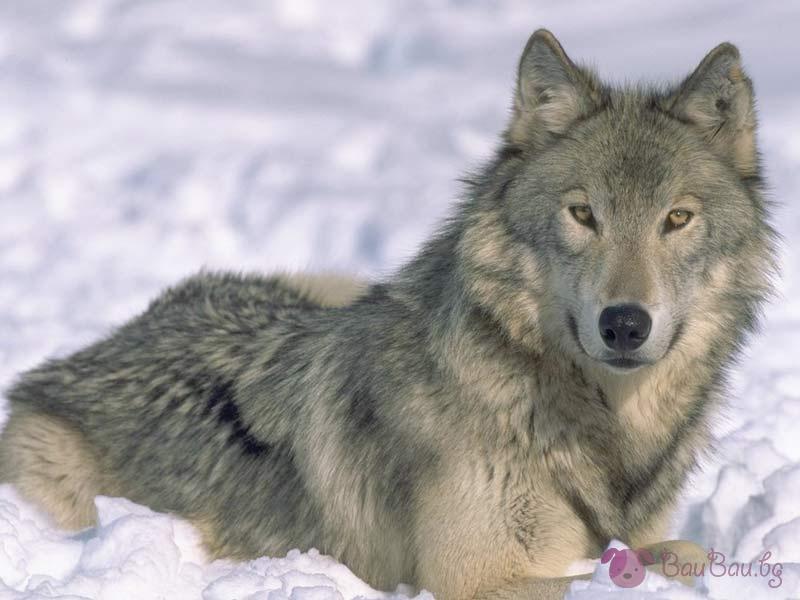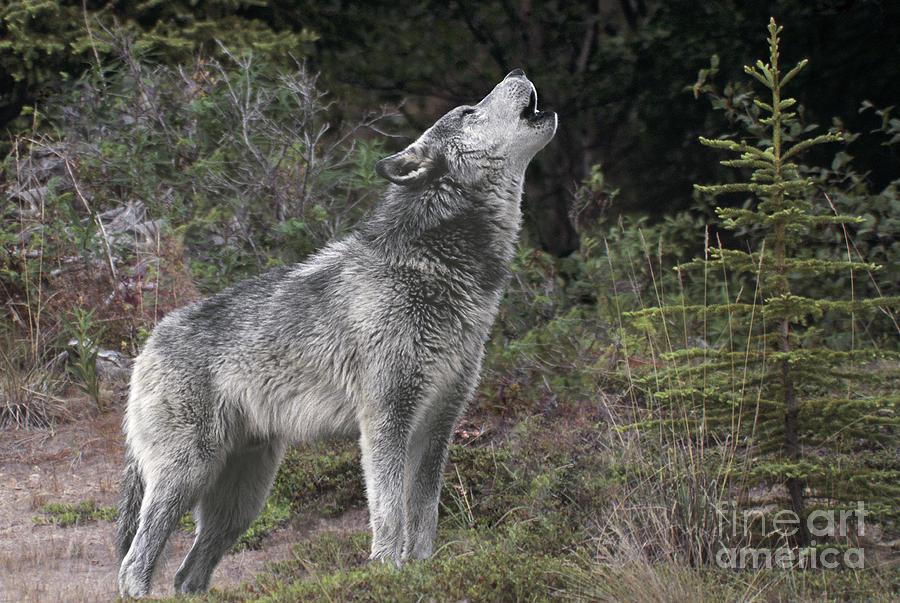The first image is the image on the left, the second image is the image on the right. Evaluate the accuracy of this statement regarding the images: "Each dog is howling in the snow.". Is it true? Answer yes or no. No. The first image is the image on the left, the second image is the image on the right. Examine the images to the left and right. Is the description "All wolves are howling, all scenes contain snow, and no image contains more than one wolf." accurate? Answer yes or no. No. 